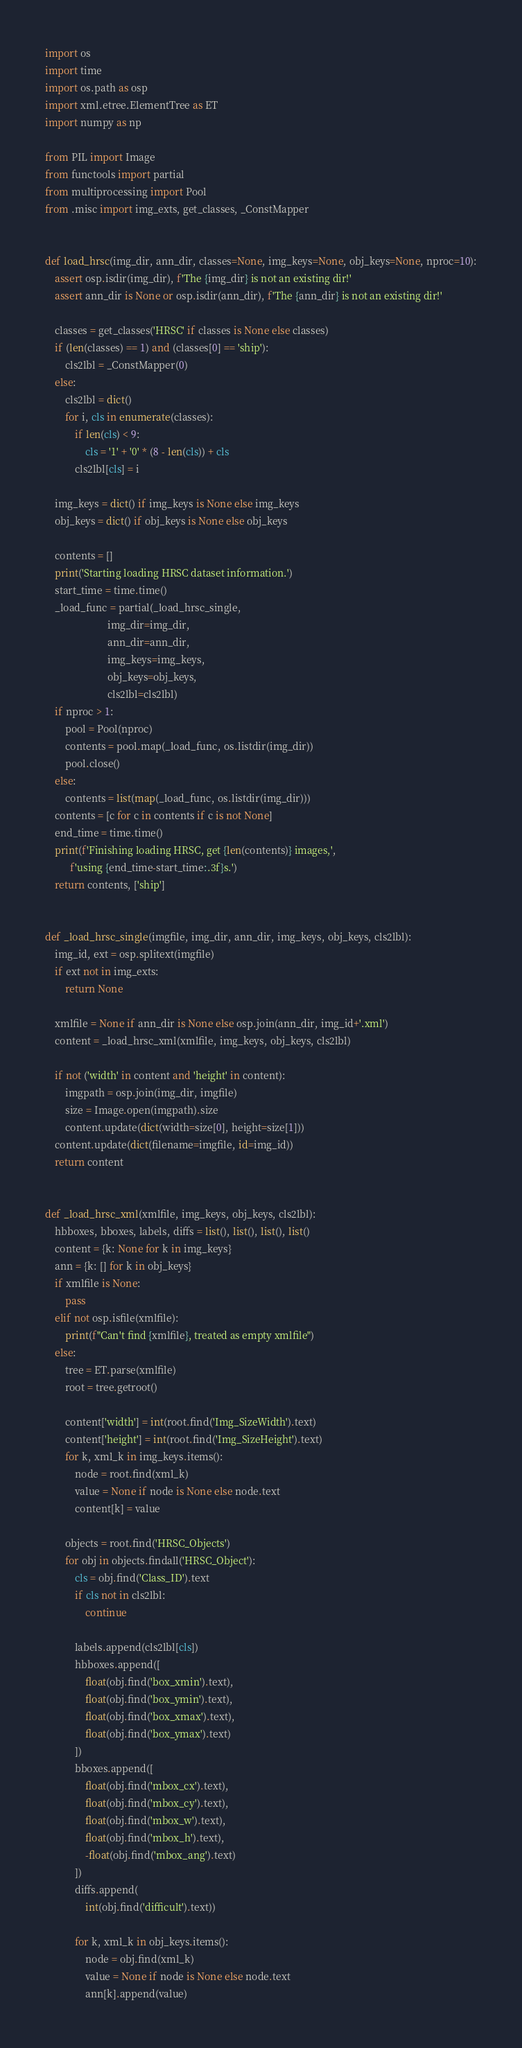<code> <loc_0><loc_0><loc_500><loc_500><_Python_>import os
import time
import os.path as osp
import xml.etree.ElementTree as ET
import numpy as np

from PIL import Image
from functools import partial
from multiprocessing import Pool
from .misc import img_exts, get_classes, _ConstMapper


def load_hrsc(img_dir, ann_dir, classes=None, img_keys=None, obj_keys=None, nproc=10):
    assert osp.isdir(img_dir), f'The {img_dir} is not an existing dir!'
    assert ann_dir is None or osp.isdir(ann_dir), f'The {ann_dir} is not an existing dir!'

    classes = get_classes('HRSC' if classes is None else classes)
    if (len(classes) == 1) and (classes[0] == 'ship'):
        cls2lbl = _ConstMapper(0)
    else:
        cls2lbl = dict()
        for i, cls in enumerate(classes):
            if len(cls) < 9:
                cls = '1' + '0' * (8 - len(cls)) + cls
            cls2lbl[cls] = i

    img_keys = dict() if img_keys is None else img_keys
    obj_keys = dict() if obj_keys is None else obj_keys

    contents = []
    print('Starting loading HRSC dataset information.')
    start_time = time.time()
    _load_func = partial(_load_hrsc_single,
                         img_dir=img_dir,
                         ann_dir=ann_dir,
                         img_keys=img_keys,
                         obj_keys=obj_keys,
                         cls2lbl=cls2lbl)
    if nproc > 1:
        pool = Pool(nproc)
        contents = pool.map(_load_func, os.listdir(img_dir))
        pool.close()
    else:
        contents = list(map(_load_func, os.listdir(img_dir)))
    contents = [c for c in contents if c is not None]
    end_time = time.time()
    print(f'Finishing loading HRSC, get {len(contents)} images,',
          f'using {end_time-start_time:.3f}s.')
    return contents, ['ship']


def _load_hrsc_single(imgfile, img_dir, ann_dir, img_keys, obj_keys, cls2lbl):
    img_id, ext = osp.splitext(imgfile)
    if ext not in img_exts:
        return None

    xmlfile = None if ann_dir is None else osp.join(ann_dir, img_id+'.xml')
    content = _load_hrsc_xml(xmlfile, img_keys, obj_keys, cls2lbl)

    if not ('width' in content and 'height' in content):
        imgpath = osp.join(img_dir, imgfile)
        size = Image.open(imgpath).size
        content.update(dict(width=size[0], height=size[1]))
    content.update(dict(filename=imgfile, id=img_id))
    return content


def _load_hrsc_xml(xmlfile, img_keys, obj_keys, cls2lbl):
    hbboxes, bboxes, labels, diffs = list(), list(), list(), list()
    content = {k: None for k in img_keys}
    ann = {k: [] for k in obj_keys}
    if xmlfile is None:
        pass
    elif not osp.isfile(xmlfile):
        print(f"Can't find {xmlfile}, treated as empty xmlfile")
    else:
        tree = ET.parse(xmlfile)
        root = tree.getroot()

        content['width'] = int(root.find('Img_SizeWidth').text)
        content['height'] = int(root.find('Img_SizeHeight').text)
        for k, xml_k in img_keys.items():
            node = root.find(xml_k)
            value = None if node is None else node.text
            content[k] = value

        objects = root.find('HRSC_Objects')
        for obj in objects.findall('HRSC_Object'):
            cls = obj.find('Class_ID').text
            if cls not in cls2lbl:
                continue

            labels.append(cls2lbl[cls])
            hbboxes.append([
                float(obj.find('box_xmin').text),
                float(obj.find('box_ymin').text),
                float(obj.find('box_xmax').text),
                float(obj.find('box_ymax').text)
            ])
            bboxes.append([
                float(obj.find('mbox_cx').text),
                float(obj.find('mbox_cy').text),
                float(obj.find('mbox_w').text),
                float(obj.find('mbox_h').text),
                -float(obj.find('mbox_ang').text)
            ])
            diffs.append(
                int(obj.find('difficult').text))

            for k, xml_k in obj_keys.items():
                node = obj.find(xml_k)
                value = None if node is None else node.text
                ann[k].append(value)
</code> 